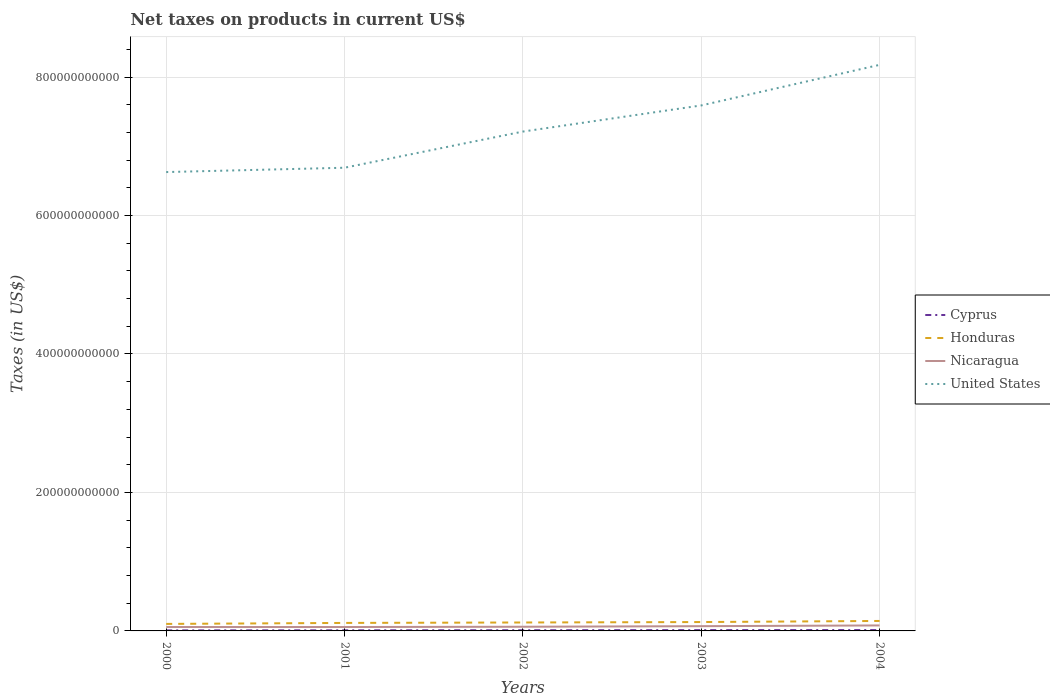Does the line corresponding to Nicaragua intersect with the line corresponding to United States?
Provide a succinct answer. No. Is the number of lines equal to the number of legend labels?
Provide a short and direct response. Yes. Across all years, what is the maximum net taxes on products in Cyprus?
Your answer should be compact. 7.73e+08. In which year was the net taxes on products in Cyprus maximum?
Keep it short and to the point. 2000. What is the total net taxes on products in Honduras in the graph?
Provide a short and direct response. -2.06e+09. What is the difference between the highest and the second highest net taxes on products in Nicaragua?
Offer a terse response. 2.28e+09. Is the net taxes on products in Honduras strictly greater than the net taxes on products in Nicaragua over the years?
Keep it short and to the point. No. How many lines are there?
Offer a very short reply. 4. How many years are there in the graph?
Ensure brevity in your answer.  5. What is the difference between two consecutive major ticks on the Y-axis?
Ensure brevity in your answer.  2.00e+11. Where does the legend appear in the graph?
Your answer should be compact. Center right. What is the title of the graph?
Offer a terse response. Net taxes on products in current US$. What is the label or title of the Y-axis?
Your answer should be very brief. Taxes (in US$). What is the Taxes (in US$) in Cyprus in 2000?
Keep it short and to the point. 7.73e+08. What is the Taxes (in US$) of Honduras in 2000?
Your answer should be compact. 1.01e+1. What is the Taxes (in US$) of Nicaragua in 2000?
Your response must be concise. 5.64e+09. What is the Taxes (in US$) of United States in 2000?
Your answer should be compact. 6.63e+11. What is the Taxes (in US$) in Cyprus in 2001?
Give a very brief answer. 8.80e+08. What is the Taxes (in US$) of Honduras in 2001?
Your response must be concise. 1.15e+1. What is the Taxes (in US$) of Nicaragua in 2001?
Your answer should be very brief. 5.63e+09. What is the Taxes (in US$) of United States in 2001?
Make the answer very short. 6.69e+11. What is the Taxes (in US$) in Cyprus in 2002?
Give a very brief answer. 9.95e+08. What is the Taxes (in US$) in Honduras in 2002?
Offer a terse response. 1.22e+1. What is the Taxes (in US$) of Nicaragua in 2002?
Provide a succinct answer. 6.03e+09. What is the Taxes (in US$) in United States in 2002?
Give a very brief answer. 7.21e+11. What is the Taxes (in US$) in Cyprus in 2003?
Provide a short and direct response. 1.16e+09. What is the Taxes (in US$) of Honduras in 2003?
Give a very brief answer. 1.28e+1. What is the Taxes (in US$) in Nicaragua in 2003?
Provide a succinct answer. 6.87e+09. What is the Taxes (in US$) in United States in 2003?
Your answer should be compact. 7.59e+11. What is the Taxes (in US$) of Cyprus in 2004?
Provide a short and direct response. 1.25e+09. What is the Taxes (in US$) in Honduras in 2004?
Give a very brief answer. 1.44e+1. What is the Taxes (in US$) of Nicaragua in 2004?
Provide a succinct answer. 7.91e+09. What is the Taxes (in US$) in United States in 2004?
Make the answer very short. 8.18e+11. Across all years, what is the maximum Taxes (in US$) in Cyprus?
Offer a very short reply. 1.25e+09. Across all years, what is the maximum Taxes (in US$) in Honduras?
Give a very brief answer. 1.44e+1. Across all years, what is the maximum Taxes (in US$) in Nicaragua?
Your answer should be very brief. 7.91e+09. Across all years, what is the maximum Taxes (in US$) in United States?
Make the answer very short. 8.18e+11. Across all years, what is the minimum Taxes (in US$) of Cyprus?
Give a very brief answer. 7.73e+08. Across all years, what is the minimum Taxes (in US$) in Honduras?
Your answer should be very brief. 1.01e+1. Across all years, what is the minimum Taxes (in US$) of Nicaragua?
Offer a very short reply. 5.63e+09. Across all years, what is the minimum Taxes (in US$) of United States?
Keep it short and to the point. 6.63e+11. What is the total Taxes (in US$) of Cyprus in the graph?
Ensure brevity in your answer.  5.06e+09. What is the total Taxes (in US$) of Honduras in the graph?
Make the answer very short. 6.11e+1. What is the total Taxes (in US$) in Nicaragua in the graph?
Ensure brevity in your answer.  3.21e+1. What is the total Taxes (in US$) of United States in the graph?
Your response must be concise. 3.63e+12. What is the difference between the Taxes (in US$) of Cyprus in 2000 and that in 2001?
Ensure brevity in your answer.  -1.08e+08. What is the difference between the Taxes (in US$) in Honduras in 2000 and that in 2001?
Your answer should be very brief. -1.43e+09. What is the difference between the Taxes (in US$) of Nicaragua in 2000 and that in 2001?
Offer a terse response. 7.90e+06. What is the difference between the Taxes (in US$) in United States in 2000 and that in 2001?
Provide a short and direct response. -6.25e+09. What is the difference between the Taxes (in US$) in Cyprus in 2000 and that in 2002?
Offer a very short reply. -2.22e+08. What is the difference between the Taxes (in US$) of Honduras in 2000 and that in 2002?
Ensure brevity in your answer.  -2.06e+09. What is the difference between the Taxes (in US$) in Nicaragua in 2000 and that in 2002?
Your response must be concise. -3.89e+08. What is the difference between the Taxes (in US$) of United States in 2000 and that in 2002?
Keep it short and to the point. -5.85e+1. What is the difference between the Taxes (in US$) of Cyprus in 2000 and that in 2003?
Offer a terse response. -3.89e+08. What is the difference between the Taxes (in US$) of Honduras in 2000 and that in 2003?
Ensure brevity in your answer.  -2.70e+09. What is the difference between the Taxes (in US$) in Nicaragua in 2000 and that in 2003?
Give a very brief answer. -1.22e+09. What is the difference between the Taxes (in US$) in United States in 2000 and that in 2003?
Your answer should be compact. -9.62e+1. What is the difference between the Taxes (in US$) in Cyprus in 2000 and that in 2004?
Provide a succinct answer. -4.74e+08. What is the difference between the Taxes (in US$) in Honduras in 2000 and that in 2004?
Make the answer very short. -4.28e+09. What is the difference between the Taxes (in US$) of Nicaragua in 2000 and that in 2004?
Keep it short and to the point. -2.27e+09. What is the difference between the Taxes (in US$) of United States in 2000 and that in 2004?
Provide a succinct answer. -1.55e+11. What is the difference between the Taxes (in US$) in Cyprus in 2001 and that in 2002?
Provide a short and direct response. -1.14e+08. What is the difference between the Taxes (in US$) of Honduras in 2001 and that in 2002?
Ensure brevity in your answer.  -6.32e+08. What is the difference between the Taxes (in US$) of Nicaragua in 2001 and that in 2002?
Your answer should be compact. -3.96e+08. What is the difference between the Taxes (in US$) of United States in 2001 and that in 2002?
Provide a short and direct response. -5.22e+1. What is the difference between the Taxes (in US$) in Cyprus in 2001 and that in 2003?
Provide a succinct answer. -2.82e+08. What is the difference between the Taxes (in US$) of Honduras in 2001 and that in 2003?
Ensure brevity in your answer.  -1.27e+09. What is the difference between the Taxes (in US$) of Nicaragua in 2001 and that in 2003?
Your answer should be compact. -1.23e+09. What is the difference between the Taxes (in US$) of United States in 2001 and that in 2003?
Make the answer very short. -9.00e+1. What is the difference between the Taxes (in US$) in Cyprus in 2001 and that in 2004?
Offer a very short reply. -3.66e+08. What is the difference between the Taxes (in US$) of Honduras in 2001 and that in 2004?
Give a very brief answer. -2.85e+09. What is the difference between the Taxes (in US$) of Nicaragua in 2001 and that in 2004?
Give a very brief answer. -2.28e+09. What is the difference between the Taxes (in US$) of United States in 2001 and that in 2004?
Offer a terse response. -1.49e+11. What is the difference between the Taxes (in US$) of Cyprus in 2002 and that in 2003?
Give a very brief answer. -1.68e+08. What is the difference between the Taxes (in US$) in Honduras in 2002 and that in 2003?
Provide a short and direct response. -6.37e+08. What is the difference between the Taxes (in US$) of Nicaragua in 2002 and that in 2003?
Ensure brevity in your answer.  -8.34e+08. What is the difference between the Taxes (in US$) in United States in 2002 and that in 2003?
Make the answer very short. -3.77e+1. What is the difference between the Taxes (in US$) of Cyprus in 2002 and that in 2004?
Make the answer very short. -2.52e+08. What is the difference between the Taxes (in US$) in Honduras in 2002 and that in 2004?
Your answer should be very brief. -2.22e+09. What is the difference between the Taxes (in US$) in Nicaragua in 2002 and that in 2004?
Ensure brevity in your answer.  -1.88e+09. What is the difference between the Taxes (in US$) of United States in 2002 and that in 2004?
Your response must be concise. -9.63e+1. What is the difference between the Taxes (in US$) of Cyprus in 2003 and that in 2004?
Your answer should be compact. -8.43e+07. What is the difference between the Taxes (in US$) of Honduras in 2003 and that in 2004?
Give a very brief answer. -1.58e+09. What is the difference between the Taxes (in US$) in Nicaragua in 2003 and that in 2004?
Your answer should be compact. -1.05e+09. What is the difference between the Taxes (in US$) in United States in 2003 and that in 2004?
Provide a short and direct response. -5.86e+1. What is the difference between the Taxes (in US$) in Cyprus in 2000 and the Taxes (in US$) in Honduras in 2001?
Your answer should be very brief. -1.08e+1. What is the difference between the Taxes (in US$) of Cyprus in 2000 and the Taxes (in US$) of Nicaragua in 2001?
Your answer should be very brief. -4.86e+09. What is the difference between the Taxes (in US$) in Cyprus in 2000 and the Taxes (in US$) in United States in 2001?
Provide a succinct answer. -6.68e+11. What is the difference between the Taxes (in US$) in Honduras in 2000 and the Taxes (in US$) in Nicaragua in 2001?
Offer a very short reply. 4.48e+09. What is the difference between the Taxes (in US$) of Honduras in 2000 and the Taxes (in US$) of United States in 2001?
Your answer should be very brief. -6.59e+11. What is the difference between the Taxes (in US$) in Nicaragua in 2000 and the Taxes (in US$) in United States in 2001?
Your response must be concise. -6.63e+11. What is the difference between the Taxes (in US$) in Cyprus in 2000 and the Taxes (in US$) in Honduras in 2002?
Offer a terse response. -1.14e+1. What is the difference between the Taxes (in US$) in Cyprus in 2000 and the Taxes (in US$) in Nicaragua in 2002?
Offer a terse response. -5.26e+09. What is the difference between the Taxes (in US$) of Cyprus in 2000 and the Taxes (in US$) of United States in 2002?
Offer a terse response. -7.20e+11. What is the difference between the Taxes (in US$) in Honduras in 2000 and the Taxes (in US$) in Nicaragua in 2002?
Provide a short and direct response. 4.09e+09. What is the difference between the Taxes (in US$) in Honduras in 2000 and the Taxes (in US$) in United States in 2002?
Your response must be concise. -7.11e+11. What is the difference between the Taxes (in US$) of Nicaragua in 2000 and the Taxes (in US$) of United States in 2002?
Offer a very short reply. -7.16e+11. What is the difference between the Taxes (in US$) in Cyprus in 2000 and the Taxes (in US$) in Honduras in 2003?
Your answer should be compact. -1.20e+1. What is the difference between the Taxes (in US$) of Cyprus in 2000 and the Taxes (in US$) of Nicaragua in 2003?
Offer a terse response. -6.09e+09. What is the difference between the Taxes (in US$) of Cyprus in 2000 and the Taxes (in US$) of United States in 2003?
Provide a succinct answer. -7.58e+11. What is the difference between the Taxes (in US$) of Honduras in 2000 and the Taxes (in US$) of Nicaragua in 2003?
Keep it short and to the point. 3.25e+09. What is the difference between the Taxes (in US$) of Honduras in 2000 and the Taxes (in US$) of United States in 2003?
Offer a terse response. -7.49e+11. What is the difference between the Taxes (in US$) in Nicaragua in 2000 and the Taxes (in US$) in United States in 2003?
Ensure brevity in your answer.  -7.53e+11. What is the difference between the Taxes (in US$) of Cyprus in 2000 and the Taxes (in US$) of Honduras in 2004?
Offer a terse response. -1.36e+1. What is the difference between the Taxes (in US$) of Cyprus in 2000 and the Taxes (in US$) of Nicaragua in 2004?
Ensure brevity in your answer.  -7.14e+09. What is the difference between the Taxes (in US$) of Cyprus in 2000 and the Taxes (in US$) of United States in 2004?
Give a very brief answer. -8.17e+11. What is the difference between the Taxes (in US$) in Honduras in 2000 and the Taxes (in US$) in Nicaragua in 2004?
Your answer should be compact. 2.21e+09. What is the difference between the Taxes (in US$) in Honduras in 2000 and the Taxes (in US$) in United States in 2004?
Provide a short and direct response. -8.07e+11. What is the difference between the Taxes (in US$) of Nicaragua in 2000 and the Taxes (in US$) of United States in 2004?
Offer a terse response. -8.12e+11. What is the difference between the Taxes (in US$) of Cyprus in 2001 and the Taxes (in US$) of Honduras in 2002?
Provide a succinct answer. -1.13e+1. What is the difference between the Taxes (in US$) in Cyprus in 2001 and the Taxes (in US$) in Nicaragua in 2002?
Your answer should be compact. -5.15e+09. What is the difference between the Taxes (in US$) in Cyprus in 2001 and the Taxes (in US$) in United States in 2002?
Your response must be concise. -7.20e+11. What is the difference between the Taxes (in US$) in Honduras in 2001 and the Taxes (in US$) in Nicaragua in 2002?
Keep it short and to the point. 5.52e+09. What is the difference between the Taxes (in US$) in Honduras in 2001 and the Taxes (in US$) in United States in 2002?
Your answer should be very brief. -7.10e+11. What is the difference between the Taxes (in US$) of Nicaragua in 2001 and the Taxes (in US$) of United States in 2002?
Offer a very short reply. -7.16e+11. What is the difference between the Taxes (in US$) of Cyprus in 2001 and the Taxes (in US$) of Honduras in 2003?
Your answer should be compact. -1.19e+1. What is the difference between the Taxes (in US$) in Cyprus in 2001 and the Taxes (in US$) in Nicaragua in 2003?
Give a very brief answer. -5.99e+09. What is the difference between the Taxes (in US$) in Cyprus in 2001 and the Taxes (in US$) in United States in 2003?
Your answer should be compact. -7.58e+11. What is the difference between the Taxes (in US$) of Honduras in 2001 and the Taxes (in US$) of Nicaragua in 2003?
Keep it short and to the point. 4.68e+09. What is the difference between the Taxes (in US$) of Honduras in 2001 and the Taxes (in US$) of United States in 2003?
Your answer should be very brief. -7.47e+11. What is the difference between the Taxes (in US$) in Nicaragua in 2001 and the Taxes (in US$) in United States in 2003?
Your answer should be compact. -7.53e+11. What is the difference between the Taxes (in US$) of Cyprus in 2001 and the Taxes (in US$) of Honduras in 2004?
Your response must be concise. -1.35e+1. What is the difference between the Taxes (in US$) of Cyprus in 2001 and the Taxes (in US$) of Nicaragua in 2004?
Keep it short and to the point. -7.03e+09. What is the difference between the Taxes (in US$) in Cyprus in 2001 and the Taxes (in US$) in United States in 2004?
Provide a short and direct response. -8.17e+11. What is the difference between the Taxes (in US$) of Honduras in 2001 and the Taxes (in US$) of Nicaragua in 2004?
Your answer should be very brief. 3.64e+09. What is the difference between the Taxes (in US$) of Honduras in 2001 and the Taxes (in US$) of United States in 2004?
Provide a short and direct response. -8.06e+11. What is the difference between the Taxes (in US$) in Nicaragua in 2001 and the Taxes (in US$) in United States in 2004?
Ensure brevity in your answer.  -8.12e+11. What is the difference between the Taxes (in US$) of Cyprus in 2002 and the Taxes (in US$) of Honduras in 2003?
Your answer should be compact. -1.18e+1. What is the difference between the Taxes (in US$) of Cyprus in 2002 and the Taxes (in US$) of Nicaragua in 2003?
Your answer should be compact. -5.87e+09. What is the difference between the Taxes (in US$) of Cyprus in 2002 and the Taxes (in US$) of United States in 2003?
Your answer should be very brief. -7.58e+11. What is the difference between the Taxes (in US$) of Honduras in 2002 and the Taxes (in US$) of Nicaragua in 2003?
Your answer should be compact. 5.32e+09. What is the difference between the Taxes (in US$) of Honduras in 2002 and the Taxes (in US$) of United States in 2003?
Make the answer very short. -7.47e+11. What is the difference between the Taxes (in US$) in Nicaragua in 2002 and the Taxes (in US$) in United States in 2003?
Offer a terse response. -7.53e+11. What is the difference between the Taxes (in US$) in Cyprus in 2002 and the Taxes (in US$) in Honduras in 2004?
Provide a short and direct response. -1.34e+1. What is the difference between the Taxes (in US$) of Cyprus in 2002 and the Taxes (in US$) of Nicaragua in 2004?
Offer a terse response. -6.92e+09. What is the difference between the Taxes (in US$) in Cyprus in 2002 and the Taxes (in US$) in United States in 2004?
Make the answer very short. -8.17e+11. What is the difference between the Taxes (in US$) in Honduras in 2002 and the Taxes (in US$) in Nicaragua in 2004?
Ensure brevity in your answer.  4.27e+09. What is the difference between the Taxes (in US$) of Honduras in 2002 and the Taxes (in US$) of United States in 2004?
Your answer should be very brief. -8.05e+11. What is the difference between the Taxes (in US$) of Nicaragua in 2002 and the Taxes (in US$) of United States in 2004?
Provide a succinct answer. -8.12e+11. What is the difference between the Taxes (in US$) of Cyprus in 2003 and the Taxes (in US$) of Honduras in 2004?
Ensure brevity in your answer.  -1.32e+1. What is the difference between the Taxes (in US$) of Cyprus in 2003 and the Taxes (in US$) of Nicaragua in 2004?
Keep it short and to the point. -6.75e+09. What is the difference between the Taxes (in US$) of Cyprus in 2003 and the Taxes (in US$) of United States in 2004?
Ensure brevity in your answer.  -8.16e+11. What is the difference between the Taxes (in US$) in Honduras in 2003 and the Taxes (in US$) in Nicaragua in 2004?
Your response must be concise. 4.91e+09. What is the difference between the Taxes (in US$) of Honduras in 2003 and the Taxes (in US$) of United States in 2004?
Your answer should be compact. -8.05e+11. What is the difference between the Taxes (in US$) in Nicaragua in 2003 and the Taxes (in US$) in United States in 2004?
Your response must be concise. -8.11e+11. What is the average Taxes (in US$) of Cyprus per year?
Your answer should be compact. 1.01e+09. What is the average Taxes (in US$) in Honduras per year?
Ensure brevity in your answer.  1.22e+1. What is the average Taxes (in US$) in Nicaragua per year?
Provide a short and direct response. 6.42e+09. What is the average Taxes (in US$) of United States per year?
Provide a short and direct response. 7.26e+11. In the year 2000, what is the difference between the Taxes (in US$) of Cyprus and Taxes (in US$) of Honduras?
Provide a succinct answer. -9.35e+09. In the year 2000, what is the difference between the Taxes (in US$) of Cyprus and Taxes (in US$) of Nicaragua?
Offer a terse response. -4.87e+09. In the year 2000, what is the difference between the Taxes (in US$) of Cyprus and Taxes (in US$) of United States?
Provide a succinct answer. -6.62e+11. In the year 2000, what is the difference between the Taxes (in US$) in Honduras and Taxes (in US$) in Nicaragua?
Give a very brief answer. 4.48e+09. In the year 2000, what is the difference between the Taxes (in US$) of Honduras and Taxes (in US$) of United States?
Ensure brevity in your answer.  -6.53e+11. In the year 2000, what is the difference between the Taxes (in US$) in Nicaragua and Taxes (in US$) in United States?
Your answer should be very brief. -6.57e+11. In the year 2001, what is the difference between the Taxes (in US$) of Cyprus and Taxes (in US$) of Honduras?
Your answer should be compact. -1.07e+1. In the year 2001, what is the difference between the Taxes (in US$) of Cyprus and Taxes (in US$) of Nicaragua?
Your response must be concise. -4.75e+09. In the year 2001, what is the difference between the Taxes (in US$) in Cyprus and Taxes (in US$) in United States?
Keep it short and to the point. -6.68e+11. In the year 2001, what is the difference between the Taxes (in US$) of Honduras and Taxes (in US$) of Nicaragua?
Ensure brevity in your answer.  5.91e+09. In the year 2001, what is the difference between the Taxes (in US$) in Honduras and Taxes (in US$) in United States?
Provide a succinct answer. -6.57e+11. In the year 2001, what is the difference between the Taxes (in US$) in Nicaragua and Taxes (in US$) in United States?
Provide a succinct answer. -6.63e+11. In the year 2002, what is the difference between the Taxes (in US$) of Cyprus and Taxes (in US$) of Honduras?
Keep it short and to the point. -1.12e+1. In the year 2002, what is the difference between the Taxes (in US$) in Cyprus and Taxes (in US$) in Nicaragua?
Offer a very short reply. -5.04e+09. In the year 2002, what is the difference between the Taxes (in US$) in Cyprus and Taxes (in US$) in United States?
Keep it short and to the point. -7.20e+11. In the year 2002, what is the difference between the Taxes (in US$) in Honduras and Taxes (in US$) in Nicaragua?
Give a very brief answer. 6.15e+09. In the year 2002, what is the difference between the Taxes (in US$) in Honduras and Taxes (in US$) in United States?
Ensure brevity in your answer.  -7.09e+11. In the year 2002, what is the difference between the Taxes (in US$) in Nicaragua and Taxes (in US$) in United States?
Make the answer very short. -7.15e+11. In the year 2003, what is the difference between the Taxes (in US$) of Cyprus and Taxes (in US$) of Honduras?
Offer a very short reply. -1.17e+1. In the year 2003, what is the difference between the Taxes (in US$) in Cyprus and Taxes (in US$) in Nicaragua?
Offer a very short reply. -5.70e+09. In the year 2003, what is the difference between the Taxes (in US$) in Cyprus and Taxes (in US$) in United States?
Offer a terse response. -7.58e+11. In the year 2003, what is the difference between the Taxes (in US$) in Honduras and Taxes (in US$) in Nicaragua?
Offer a very short reply. 5.95e+09. In the year 2003, what is the difference between the Taxes (in US$) in Honduras and Taxes (in US$) in United States?
Provide a short and direct response. -7.46e+11. In the year 2003, what is the difference between the Taxes (in US$) of Nicaragua and Taxes (in US$) of United States?
Your answer should be compact. -7.52e+11. In the year 2004, what is the difference between the Taxes (in US$) of Cyprus and Taxes (in US$) of Honduras?
Keep it short and to the point. -1.32e+1. In the year 2004, what is the difference between the Taxes (in US$) of Cyprus and Taxes (in US$) of Nicaragua?
Ensure brevity in your answer.  -6.67e+09. In the year 2004, what is the difference between the Taxes (in US$) of Cyprus and Taxes (in US$) of United States?
Ensure brevity in your answer.  -8.16e+11. In the year 2004, what is the difference between the Taxes (in US$) of Honduras and Taxes (in US$) of Nicaragua?
Make the answer very short. 6.48e+09. In the year 2004, what is the difference between the Taxes (in US$) of Honduras and Taxes (in US$) of United States?
Keep it short and to the point. -8.03e+11. In the year 2004, what is the difference between the Taxes (in US$) of Nicaragua and Taxes (in US$) of United States?
Offer a very short reply. -8.10e+11. What is the ratio of the Taxes (in US$) in Cyprus in 2000 to that in 2001?
Your answer should be compact. 0.88. What is the ratio of the Taxes (in US$) of Honduras in 2000 to that in 2001?
Make the answer very short. 0.88. What is the ratio of the Taxes (in US$) in United States in 2000 to that in 2001?
Provide a short and direct response. 0.99. What is the ratio of the Taxes (in US$) of Cyprus in 2000 to that in 2002?
Your response must be concise. 0.78. What is the ratio of the Taxes (in US$) of Honduras in 2000 to that in 2002?
Your answer should be very brief. 0.83. What is the ratio of the Taxes (in US$) in Nicaragua in 2000 to that in 2002?
Your answer should be compact. 0.94. What is the ratio of the Taxes (in US$) of United States in 2000 to that in 2002?
Provide a short and direct response. 0.92. What is the ratio of the Taxes (in US$) of Cyprus in 2000 to that in 2003?
Offer a terse response. 0.66. What is the ratio of the Taxes (in US$) in Honduras in 2000 to that in 2003?
Your answer should be compact. 0.79. What is the ratio of the Taxes (in US$) in Nicaragua in 2000 to that in 2003?
Your response must be concise. 0.82. What is the ratio of the Taxes (in US$) of United States in 2000 to that in 2003?
Give a very brief answer. 0.87. What is the ratio of the Taxes (in US$) of Cyprus in 2000 to that in 2004?
Ensure brevity in your answer.  0.62. What is the ratio of the Taxes (in US$) in Honduras in 2000 to that in 2004?
Keep it short and to the point. 0.7. What is the ratio of the Taxes (in US$) of Nicaragua in 2000 to that in 2004?
Offer a very short reply. 0.71. What is the ratio of the Taxes (in US$) in United States in 2000 to that in 2004?
Offer a terse response. 0.81. What is the ratio of the Taxes (in US$) in Cyprus in 2001 to that in 2002?
Provide a succinct answer. 0.89. What is the ratio of the Taxes (in US$) in Honduras in 2001 to that in 2002?
Give a very brief answer. 0.95. What is the ratio of the Taxes (in US$) in Nicaragua in 2001 to that in 2002?
Your answer should be very brief. 0.93. What is the ratio of the Taxes (in US$) in United States in 2001 to that in 2002?
Keep it short and to the point. 0.93. What is the ratio of the Taxes (in US$) in Cyprus in 2001 to that in 2003?
Offer a very short reply. 0.76. What is the ratio of the Taxes (in US$) of Honduras in 2001 to that in 2003?
Keep it short and to the point. 0.9. What is the ratio of the Taxes (in US$) of Nicaragua in 2001 to that in 2003?
Keep it short and to the point. 0.82. What is the ratio of the Taxes (in US$) in United States in 2001 to that in 2003?
Give a very brief answer. 0.88. What is the ratio of the Taxes (in US$) of Cyprus in 2001 to that in 2004?
Keep it short and to the point. 0.71. What is the ratio of the Taxes (in US$) in Honduras in 2001 to that in 2004?
Give a very brief answer. 0.8. What is the ratio of the Taxes (in US$) in Nicaragua in 2001 to that in 2004?
Give a very brief answer. 0.71. What is the ratio of the Taxes (in US$) in United States in 2001 to that in 2004?
Offer a very short reply. 0.82. What is the ratio of the Taxes (in US$) of Cyprus in 2002 to that in 2003?
Give a very brief answer. 0.86. What is the ratio of the Taxes (in US$) of Honduras in 2002 to that in 2003?
Ensure brevity in your answer.  0.95. What is the ratio of the Taxes (in US$) of Nicaragua in 2002 to that in 2003?
Ensure brevity in your answer.  0.88. What is the ratio of the Taxes (in US$) of United States in 2002 to that in 2003?
Provide a succinct answer. 0.95. What is the ratio of the Taxes (in US$) of Cyprus in 2002 to that in 2004?
Provide a succinct answer. 0.8. What is the ratio of the Taxes (in US$) in Honduras in 2002 to that in 2004?
Provide a succinct answer. 0.85. What is the ratio of the Taxes (in US$) in Nicaragua in 2002 to that in 2004?
Keep it short and to the point. 0.76. What is the ratio of the Taxes (in US$) in United States in 2002 to that in 2004?
Provide a short and direct response. 0.88. What is the ratio of the Taxes (in US$) in Cyprus in 2003 to that in 2004?
Your answer should be compact. 0.93. What is the ratio of the Taxes (in US$) of Honduras in 2003 to that in 2004?
Give a very brief answer. 0.89. What is the ratio of the Taxes (in US$) in Nicaragua in 2003 to that in 2004?
Your answer should be very brief. 0.87. What is the ratio of the Taxes (in US$) in United States in 2003 to that in 2004?
Give a very brief answer. 0.93. What is the difference between the highest and the second highest Taxes (in US$) of Cyprus?
Your response must be concise. 8.43e+07. What is the difference between the highest and the second highest Taxes (in US$) of Honduras?
Your response must be concise. 1.58e+09. What is the difference between the highest and the second highest Taxes (in US$) of Nicaragua?
Keep it short and to the point. 1.05e+09. What is the difference between the highest and the second highest Taxes (in US$) in United States?
Make the answer very short. 5.86e+1. What is the difference between the highest and the lowest Taxes (in US$) of Cyprus?
Ensure brevity in your answer.  4.74e+08. What is the difference between the highest and the lowest Taxes (in US$) of Honduras?
Provide a short and direct response. 4.28e+09. What is the difference between the highest and the lowest Taxes (in US$) in Nicaragua?
Make the answer very short. 2.28e+09. What is the difference between the highest and the lowest Taxes (in US$) of United States?
Provide a succinct answer. 1.55e+11. 